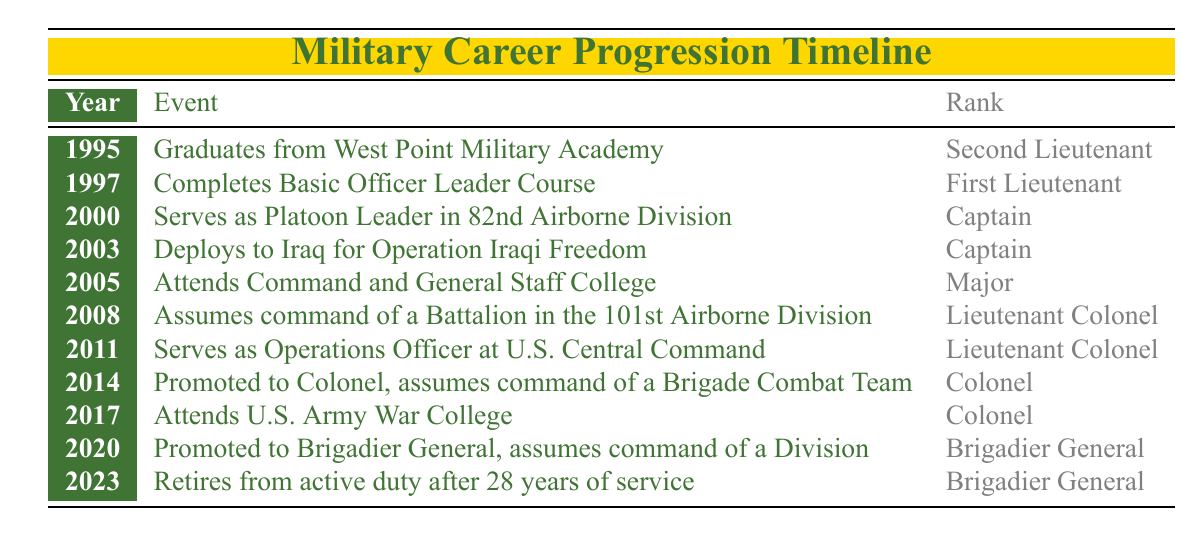What year did the officer graduate from West Point Military Academy? The officer graduated in 1995 according to the first row of the timeline table.
Answer: 1995 What rank did the officer achieve after completing the Basic Officer Leader Course? After completing the Basic Officer Leader Course in 1997, the officer's rank listed in the second row is First Lieutenant.
Answer: First Lieutenant How many years did it take for the officer to be promoted from Second Lieutenant to Colonel? The officer was promoted from Second Lieutenant in 1995 to Colonel in 2014. The difference in years is 2014 - 1995 = 19 years.
Answer: 19 years Did the officer serve as a Captain during any deployments? Yes, the officer served as a Captain during both events listed in 2000 and 2003. The first event mentions the officer serving as a Platoon Leader and the second mentions deployment for Operation Iraqi Freedom, both while holding the rank of Captain.
Answer: Yes What was the officer's rank immediately before retiring in 2023? The officer's rank immediately before retirement in 2023, as noted in the last row, was Brigadier General, which is consistent with the previous row for the year 2020.
Answer: Brigadier General What is the difference in rank between the officer at their first event and their final event? The officer started as a Second Lieutenant in 1995 and retired as a Brigadier General in 2023. The ranks increase from Second Lieutenant to Brigadier General, which is a difference of five ranks (Second Lieutenant, First Lieutenant, Captain, Major, Lieutenant Colonel, Colonel, Brigadier General).
Answer: 5 ranks In which year did the officer command a Battalion? The officer commanded a Battalion in 2008, as indicated in that row of the timeline.
Answer: 2008 How many significant events were listed at the rank of Colonel? There are three events listed under the rank of Colonel: assuming command of a Brigade Combat Team in 2014, attending the U.S. Army War College in 2017, and the promotion to Brigadier General in 2020.
Answer: 3 events What event occurred in 2005, and what rank was the officer at that time? In 2005, the officer attended Command and General Staff College, and the rank during that event was Major, according to that row of the timeline.
Answer: Attended Command and General Staff College, Major 